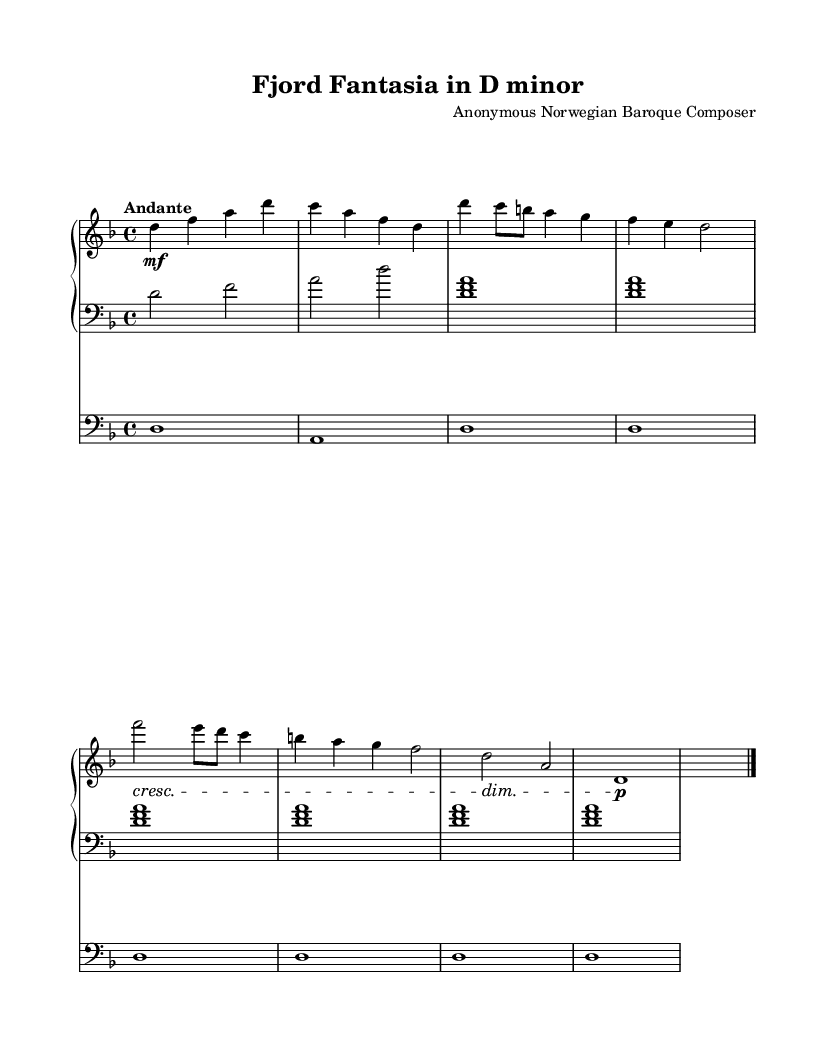What is the key signature of this music? The key signature is indicated by the absence of sharps or flats, which shows that it is in D minor.
Answer: D minor What is the time signature of this music? The time signature is located at the beginning of the piece, specified as four beats per measure, which is represented by 4/4.
Answer: 4/4 What is the tempo marking of this composition? The tempo marking is found above the staves, indicating the speed of the music, which is marked as "Andante," meaning moderately slow.
Answer: Andante How many measures are there in the introduction section? The introduction section consists of two measures as seen at the beginning of the sheet music.
Answer: 2 What is the highest note played in the right hand? The highest note in the right hand is found by looking at the notes in the staff; the highest note is D.
Answer: D What type of cadence is used at the end of the piece? The piece concludes with a perfect cadence, which is typically depicted by the root motion from V to I. Here it resolves from A to D.
Answer: Perfect What is the structure of the musical themes? The overall structure includes themes A and B which alternate throughout the piece, creating contrast, typical in Baroque compositions.
Answer: ABA 